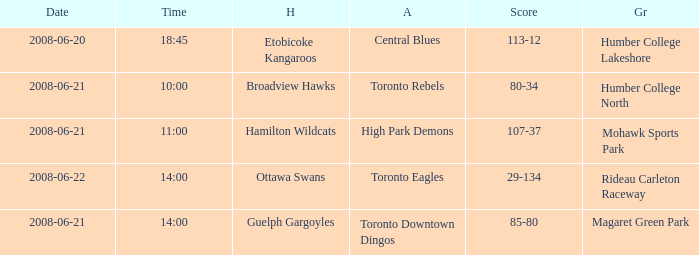What is the Away with a Ground that is humber college lakeshore? Central Blues. Parse the table in full. {'header': ['Date', 'Time', 'H', 'A', 'Score', 'Gr'], 'rows': [['2008-06-20', '18:45', 'Etobicoke Kangaroos', 'Central Blues', '113-12', 'Humber College Lakeshore'], ['2008-06-21', '10:00', 'Broadview Hawks', 'Toronto Rebels', '80-34', 'Humber College North'], ['2008-06-21', '11:00', 'Hamilton Wildcats', 'High Park Demons', '107-37', 'Mohawk Sports Park'], ['2008-06-22', '14:00', 'Ottawa Swans', 'Toronto Eagles', '29-134', 'Rideau Carleton Raceway'], ['2008-06-21', '14:00', 'Guelph Gargoyles', 'Toronto Downtown Dingos', '85-80', 'Magaret Green Park']]} 